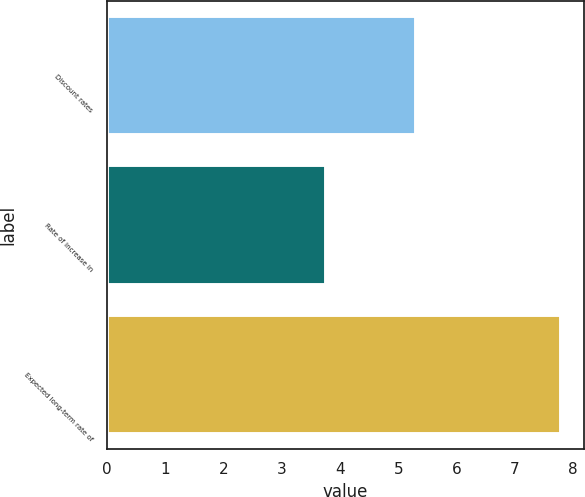Convert chart to OTSL. <chart><loc_0><loc_0><loc_500><loc_500><bar_chart><fcel>Discount rates<fcel>Rate of increase in<fcel>Expected long-term rate of<nl><fcel>5.3<fcel>3.75<fcel>7.79<nl></chart> 